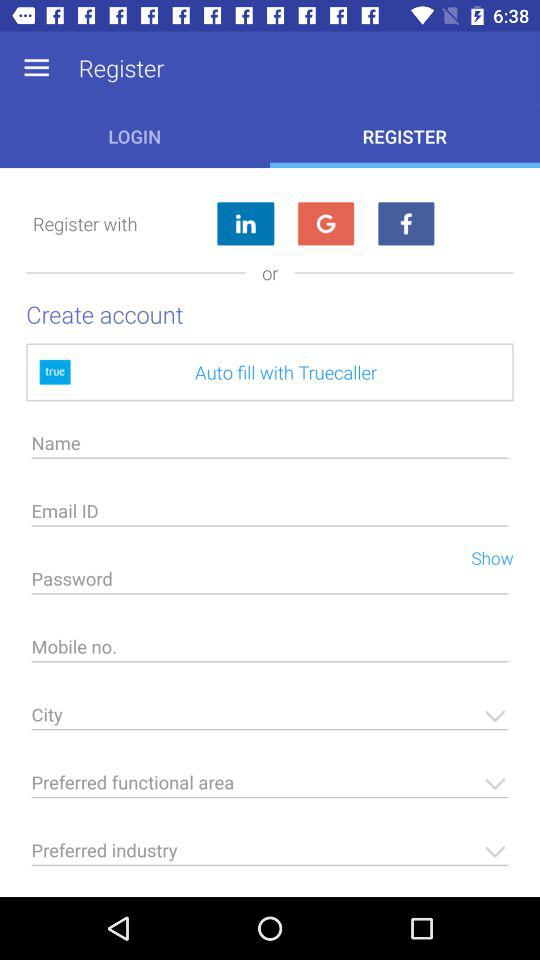Which tab is selected? The selected tab is "REGISTER". 